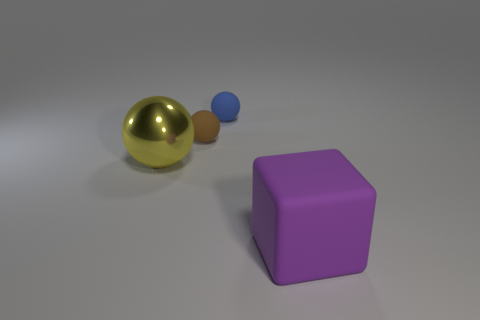How big is the brown thing?
Ensure brevity in your answer.  Small. The matte object that is in front of the blue matte ball and to the left of the large block is what color?
Your response must be concise. Brown. How many other things are there of the same shape as the small blue object?
Keep it short and to the point. 2. Is the number of brown spheres to the left of the large matte cube less than the number of tiny objects behind the yellow sphere?
Offer a very short reply. Yes. Is the blue sphere made of the same material as the large object that is on the left side of the blue rubber sphere?
Your answer should be very brief. No. Is there anything else that has the same material as the large yellow ball?
Give a very brief answer. No. Is the number of blue spheres greater than the number of big green matte balls?
Offer a very short reply. Yes. What shape is the thing that is behind the tiny object to the left of the sphere that is right of the small brown matte thing?
Your response must be concise. Sphere. Do the small sphere on the left side of the small blue rubber object and the small object that is to the right of the brown matte sphere have the same material?
Keep it short and to the point. Yes. What is the shape of the purple object that is made of the same material as the blue thing?
Keep it short and to the point. Cube. 